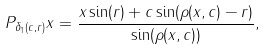<formula> <loc_0><loc_0><loc_500><loc_500>P _ { \delta _ { 1 } ( c , r ) } x = \frac { x \sin ( r ) + c \sin ( \rho ( x , c ) - r ) } { \sin ( \rho ( x , c ) ) } ,</formula> 